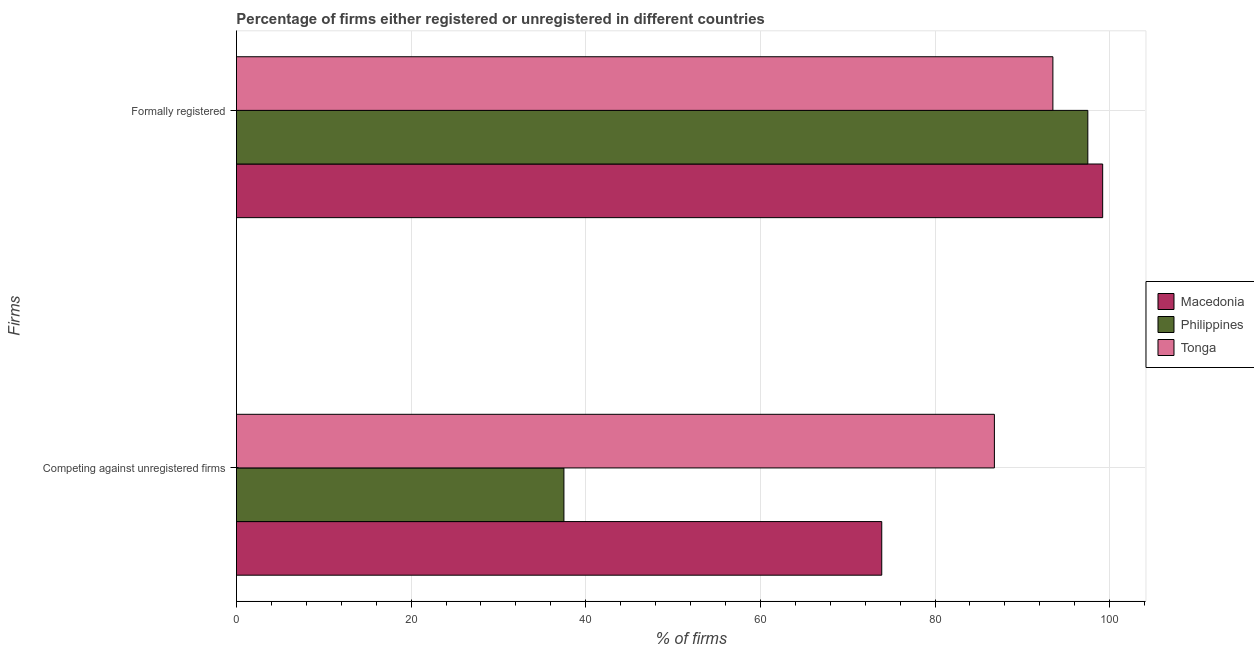How many different coloured bars are there?
Your answer should be compact. 3. How many groups of bars are there?
Your response must be concise. 2. Are the number of bars per tick equal to the number of legend labels?
Give a very brief answer. Yes. Are the number of bars on each tick of the Y-axis equal?
Offer a terse response. Yes. How many bars are there on the 2nd tick from the top?
Keep it short and to the point. 3. How many bars are there on the 2nd tick from the bottom?
Your answer should be very brief. 3. What is the label of the 1st group of bars from the top?
Your response must be concise. Formally registered. What is the percentage of registered firms in Macedonia?
Give a very brief answer. 73.9. Across all countries, what is the maximum percentage of formally registered firms?
Provide a short and direct response. 99.2. Across all countries, what is the minimum percentage of registered firms?
Provide a succinct answer. 37.5. In which country was the percentage of formally registered firms maximum?
Provide a succinct answer. Macedonia. What is the total percentage of formally registered firms in the graph?
Your answer should be very brief. 290.2. What is the difference between the percentage of formally registered firms in Tonga and that in Macedonia?
Give a very brief answer. -5.7. What is the difference between the percentage of formally registered firms in Macedonia and the percentage of registered firms in Tonga?
Make the answer very short. 12.4. What is the average percentage of registered firms per country?
Your answer should be very brief. 66.07. What is the ratio of the percentage of registered firms in Macedonia to that in Philippines?
Provide a succinct answer. 1.97. In how many countries, is the percentage of formally registered firms greater than the average percentage of formally registered firms taken over all countries?
Make the answer very short. 2. What does the 2nd bar from the top in Formally registered represents?
Your answer should be very brief. Philippines. What does the 3rd bar from the bottom in Formally registered represents?
Your answer should be compact. Tonga. Does the graph contain grids?
Your response must be concise. Yes. Where does the legend appear in the graph?
Give a very brief answer. Center right. What is the title of the graph?
Offer a very short reply. Percentage of firms either registered or unregistered in different countries. What is the label or title of the X-axis?
Provide a succinct answer. % of firms. What is the label or title of the Y-axis?
Offer a very short reply. Firms. What is the % of firms in Macedonia in Competing against unregistered firms?
Your response must be concise. 73.9. What is the % of firms of Philippines in Competing against unregistered firms?
Make the answer very short. 37.5. What is the % of firms in Tonga in Competing against unregistered firms?
Make the answer very short. 86.8. What is the % of firms of Macedonia in Formally registered?
Your answer should be very brief. 99.2. What is the % of firms of Philippines in Formally registered?
Offer a terse response. 97.5. What is the % of firms in Tonga in Formally registered?
Your answer should be very brief. 93.5. Across all Firms, what is the maximum % of firms in Macedonia?
Keep it short and to the point. 99.2. Across all Firms, what is the maximum % of firms of Philippines?
Ensure brevity in your answer.  97.5. Across all Firms, what is the maximum % of firms of Tonga?
Offer a very short reply. 93.5. Across all Firms, what is the minimum % of firms in Macedonia?
Offer a terse response. 73.9. Across all Firms, what is the minimum % of firms of Philippines?
Provide a succinct answer. 37.5. Across all Firms, what is the minimum % of firms of Tonga?
Give a very brief answer. 86.8. What is the total % of firms in Macedonia in the graph?
Provide a short and direct response. 173.1. What is the total % of firms in Philippines in the graph?
Ensure brevity in your answer.  135. What is the total % of firms of Tonga in the graph?
Provide a succinct answer. 180.3. What is the difference between the % of firms in Macedonia in Competing against unregistered firms and that in Formally registered?
Ensure brevity in your answer.  -25.3. What is the difference between the % of firms in Philippines in Competing against unregistered firms and that in Formally registered?
Provide a succinct answer. -60. What is the difference between the % of firms of Macedonia in Competing against unregistered firms and the % of firms of Philippines in Formally registered?
Give a very brief answer. -23.6. What is the difference between the % of firms of Macedonia in Competing against unregistered firms and the % of firms of Tonga in Formally registered?
Offer a very short reply. -19.6. What is the difference between the % of firms in Philippines in Competing against unregistered firms and the % of firms in Tonga in Formally registered?
Provide a short and direct response. -56. What is the average % of firms in Macedonia per Firms?
Your answer should be very brief. 86.55. What is the average % of firms in Philippines per Firms?
Make the answer very short. 67.5. What is the average % of firms of Tonga per Firms?
Provide a succinct answer. 90.15. What is the difference between the % of firms in Macedonia and % of firms in Philippines in Competing against unregistered firms?
Ensure brevity in your answer.  36.4. What is the difference between the % of firms of Macedonia and % of firms of Tonga in Competing against unregistered firms?
Your answer should be compact. -12.9. What is the difference between the % of firms in Philippines and % of firms in Tonga in Competing against unregistered firms?
Provide a short and direct response. -49.3. What is the difference between the % of firms in Philippines and % of firms in Tonga in Formally registered?
Make the answer very short. 4. What is the ratio of the % of firms in Macedonia in Competing against unregistered firms to that in Formally registered?
Your answer should be very brief. 0.74. What is the ratio of the % of firms of Philippines in Competing against unregistered firms to that in Formally registered?
Provide a short and direct response. 0.38. What is the ratio of the % of firms of Tonga in Competing against unregistered firms to that in Formally registered?
Provide a succinct answer. 0.93. What is the difference between the highest and the second highest % of firms in Macedonia?
Provide a succinct answer. 25.3. What is the difference between the highest and the second highest % of firms in Philippines?
Make the answer very short. 60. What is the difference between the highest and the lowest % of firms of Macedonia?
Your answer should be very brief. 25.3. What is the difference between the highest and the lowest % of firms of Philippines?
Provide a succinct answer. 60. 